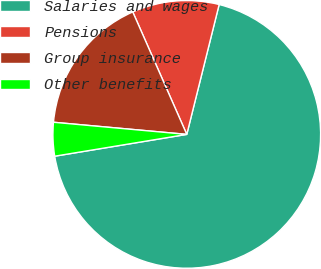Convert chart to OTSL. <chart><loc_0><loc_0><loc_500><loc_500><pie_chart><fcel>Salaries and wages<fcel>Pensions<fcel>Group insurance<fcel>Other benefits<nl><fcel>68.5%<fcel>10.5%<fcel>16.94%<fcel>4.05%<nl></chart> 